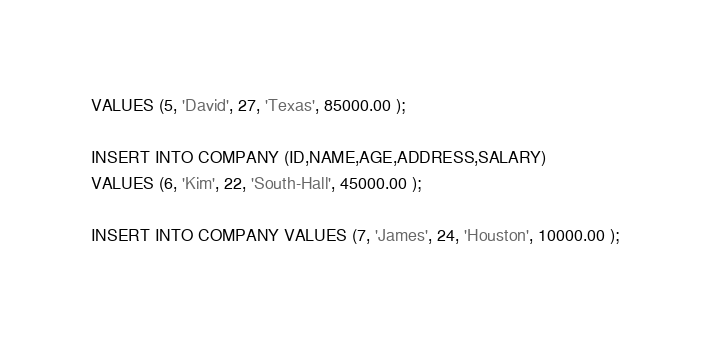Convert code to text. <code><loc_0><loc_0><loc_500><loc_500><_SQL_>VALUES (5, 'David', 27, 'Texas', 85000.00 );

INSERT INTO COMPANY (ID,NAME,AGE,ADDRESS,SALARY)
VALUES (6, 'Kim', 22, 'South-Hall', 45000.00 );

INSERT INTO COMPANY VALUES (7, 'James', 24, 'Houston', 10000.00 );</code> 